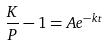Convert formula to latex. <formula><loc_0><loc_0><loc_500><loc_500>\frac { K } { P } - 1 = A e ^ { - k t }</formula> 